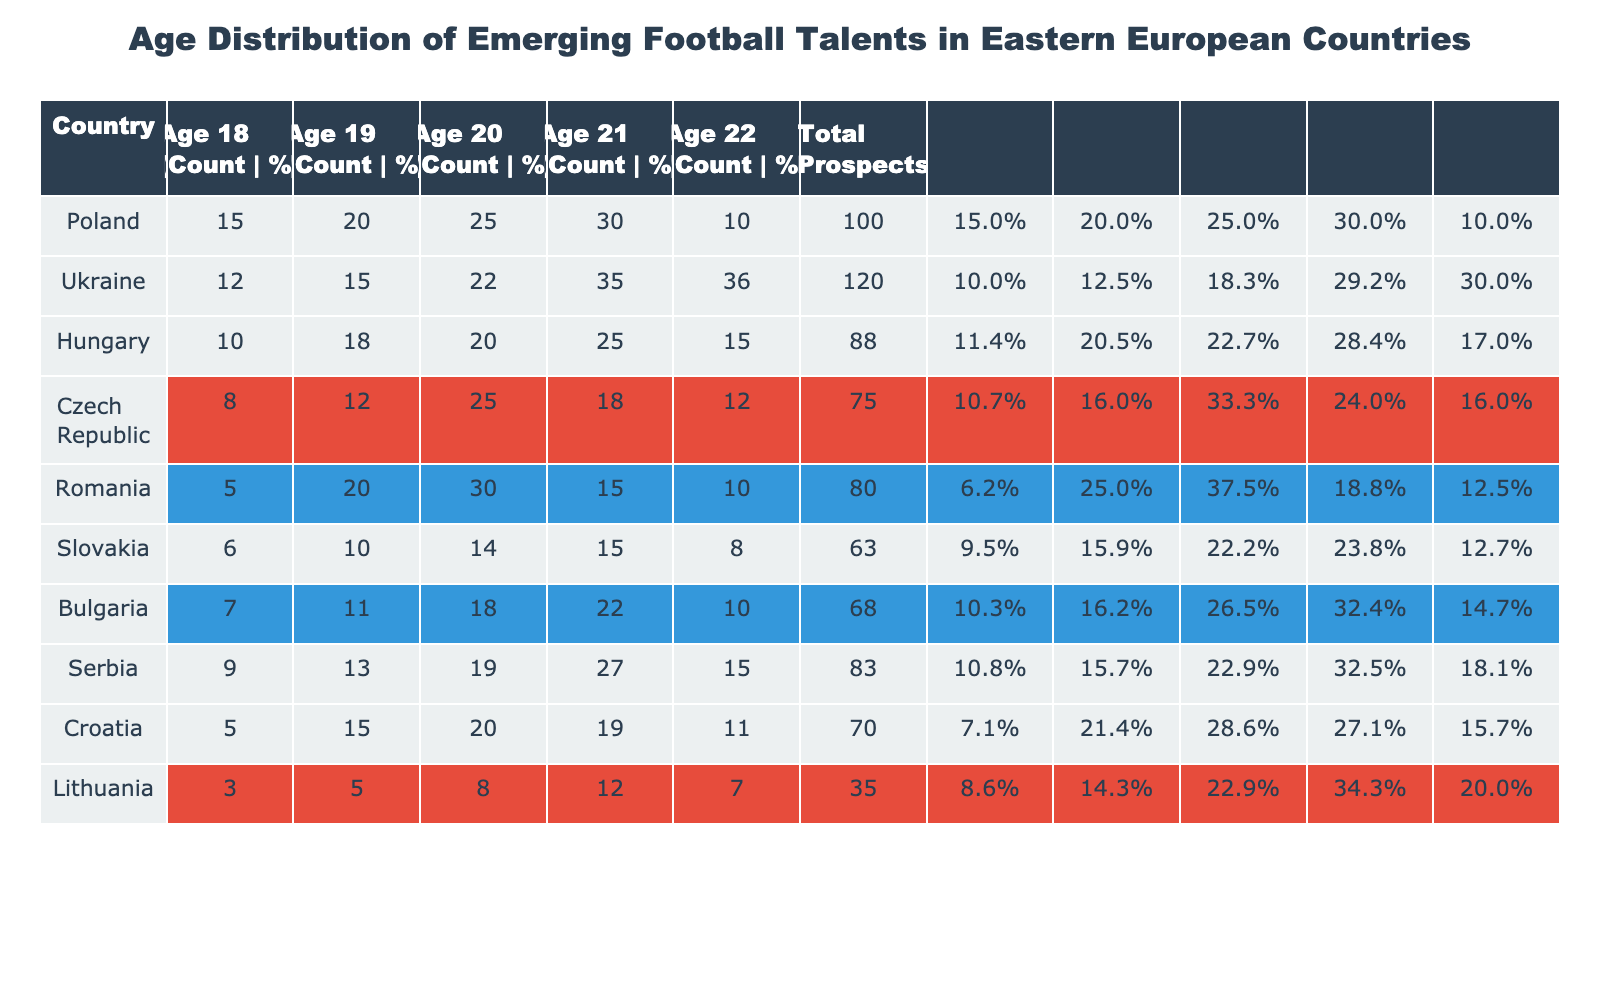What country has the highest number of prospects aged 21? By reviewing the table, we find the counts for prospects aged 21. Poland has 30 prospects (Age 21), while Ukraine has 35. Comparing all countries, Ukraine has the highest count at age 21.
Answer: Ukraine Which country has the lowest total number of prospects? The last column shows the total number of prospects for each country. Lithuania has the lowest total at 35 prospects when compared to other countries listed.
Answer: Lithuania What percentage of emerging talents in Romania are aged 20? To find the percentage of prospects aged 20 in Romania, we look at the count (30) and divide it by the total prospects (80), then multiply by 100. This gives 30/80 * 100 = 37.5%.
Answer: 37.5% How many more prospects are aged 19 in Ukraine than in Hungary? Ukraine has 15 prospects aged 19 while Hungary has 18. The difference is calculated as 15 - 18, which equals -3, meaning there are 3 fewer prospects in Ukraine compared to Hungary.
Answer: 3 fewer Is it true that the age group of 22 has more prospects in Bulgaria than in Poland? Bulgaria has 10 prospects aged 22 and Poland has 10 as well. Since these values are equal, the statement is false.
Answer: No What is the average number of prospects aged 18 across all countries? To calculate the average, we sum the prospects aged 18 (15 + 12 + 10 + 8 + 5 + 6 + 7 + 9 + 5 + 3) = 70. There are 10 countries, so we divide by 10. The average is 70 / 10 = 7.
Answer: 7 Which country has the highest percentage of prospects aged 19? We need to find the percentage of age 19 for each country: Poland (20%), Ukraine (12.5%), Hungary (20.5%), Czech Republic (16%), Romania (25%), Slovakia (15.9%), Bulgaria (16.2%), Serbia (15.7%), Croatia (21.4%), and Lithuania (14.3%). Romania has the highest percentage of prospects aged 19 at 25%.
Answer: Romania How many total prospects are there in Eastern Europe combined? To find the total across all countries, we sum the totals per country: 100 (Poland) + 120 (Ukraine) + 88 (Hungary) + 75 (Czech Republic) + 80 (Romania) + 63 (Slovakia) + 68 (Bulgaria) + 83 (Serbia) + 70 (Croatia) + 35 (Lithuania) =  100 + 120 + 88 + 75 + 80 + 63 + 68 + 83 + 70 + 35 =  992.
Answer: 992 